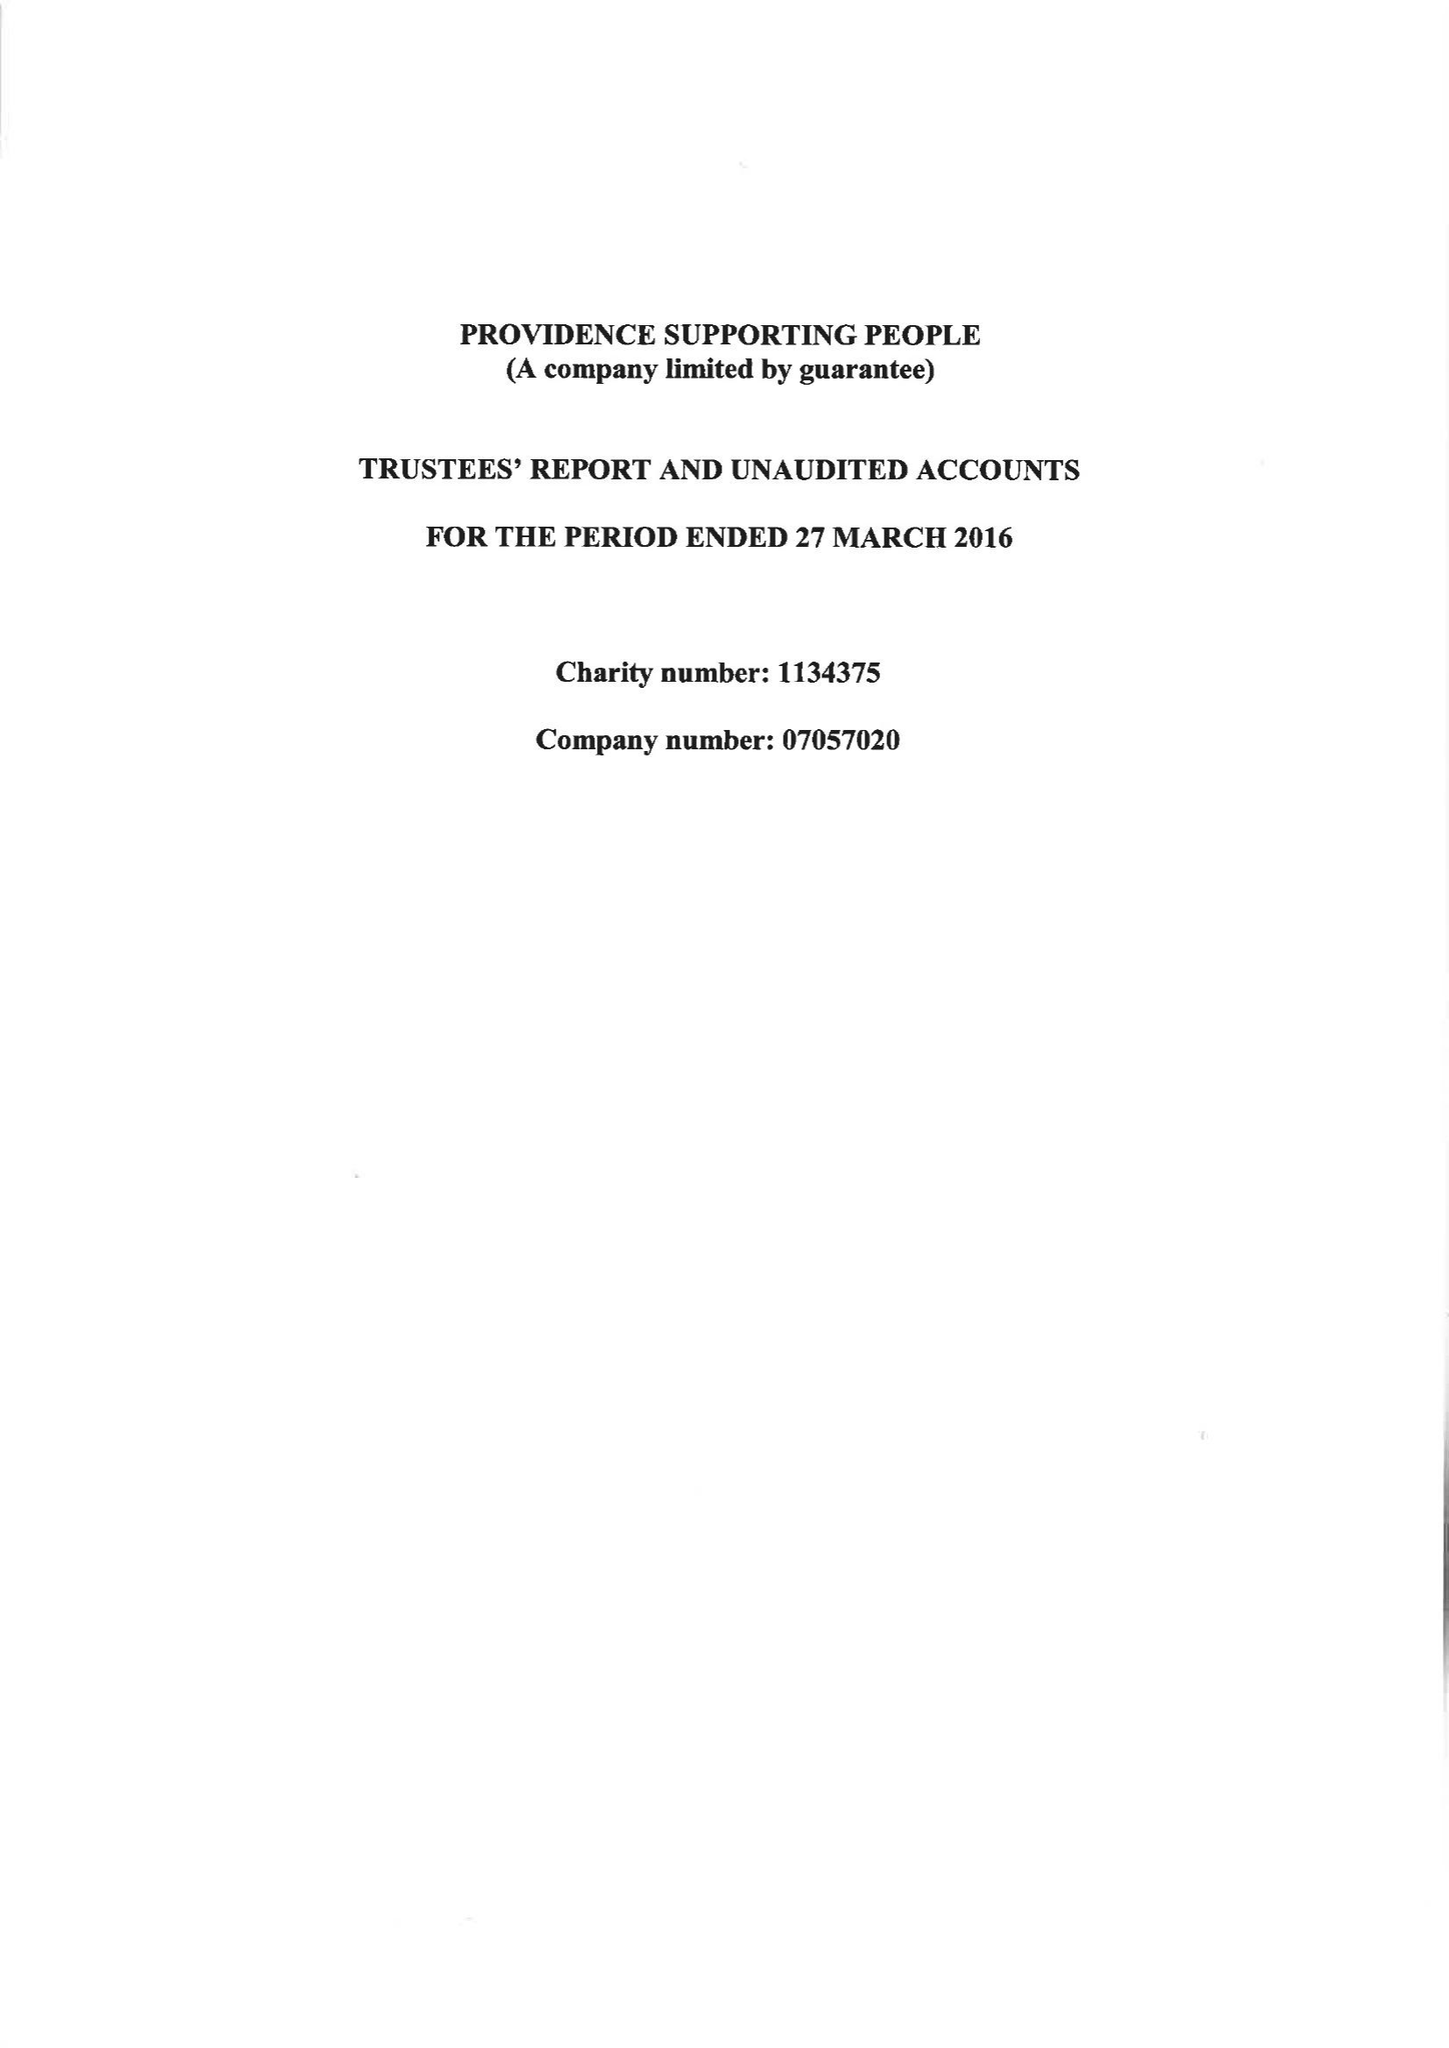What is the value for the address__post_town?
Answer the question using a single word or phrase. BOURNEMOUTH 